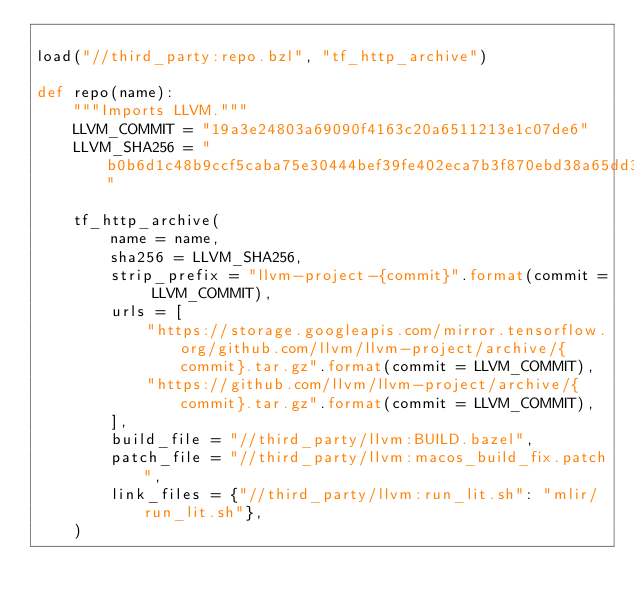Convert code to text. <code><loc_0><loc_0><loc_500><loc_500><_Python_>
load("//third_party:repo.bzl", "tf_http_archive")

def repo(name):
    """Imports LLVM."""
    LLVM_COMMIT = "19a3e24803a69090f4163c20a6511213e1c07de6"
    LLVM_SHA256 = "b0b6d1c48b9ccf5caba75e30444bef39fe402eca7b3f870ebd38a65dd33e5839"

    tf_http_archive(
        name = name,
        sha256 = LLVM_SHA256,
        strip_prefix = "llvm-project-{commit}".format(commit = LLVM_COMMIT),
        urls = [
            "https://storage.googleapis.com/mirror.tensorflow.org/github.com/llvm/llvm-project/archive/{commit}.tar.gz".format(commit = LLVM_COMMIT),
            "https://github.com/llvm/llvm-project/archive/{commit}.tar.gz".format(commit = LLVM_COMMIT),
        ],
        build_file = "//third_party/llvm:BUILD.bazel",
        patch_file = "//third_party/llvm:macos_build_fix.patch",
        link_files = {"//third_party/llvm:run_lit.sh": "mlir/run_lit.sh"},
    )
</code> 